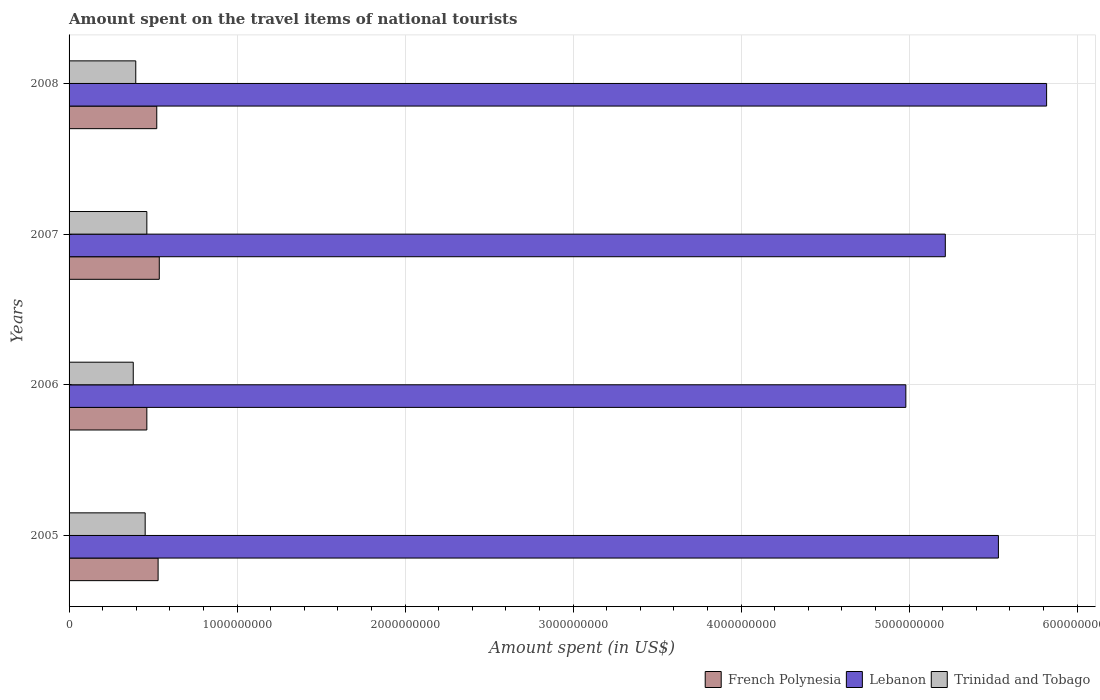Are the number of bars on each tick of the Y-axis equal?
Your response must be concise. Yes. How many bars are there on the 3rd tick from the top?
Keep it short and to the point. 3. What is the label of the 2nd group of bars from the top?
Ensure brevity in your answer.  2007. What is the amount spent on the travel items of national tourists in Trinidad and Tobago in 2008?
Your answer should be very brief. 3.97e+08. Across all years, what is the maximum amount spent on the travel items of national tourists in Lebanon?
Offer a very short reply. 5.82e+09. Across all years, what is the minimum amount spent on the travel items of national tourists in Lebanon?
Provide a short and direct response. 4.98e+09. In which year was the amount spent on the travel items of national tourists in Lebanon minimum?
Keep it short and to the point. 2006. What is the total amount spent on the travel items of national tourists in French Polynesia in the graph?
Your answer should be compact. 2.05e+09. What is the difference between the amount spent on the travel items of national tourists in French Polynesia in 2005 and that in 2007?
Keep it short and to the point. -7.00e+06. What is the difference between the amount spent on the travel items of national tourists in Trinidad and Tobago in 2006 and the amount spent on the travel items of national tourists in Lebanon in 2007?
Offer a very short reply. -4.83e+09. What is the average amount spent on the travel items of national tourists in French Polynesia per year?
Keep it short and to the point. 5.13e+08. In the year 2005, what is the difference between the amount spent on the travel items of national tourists in Trinidad and Tobago and amount spent on the travel items of national tourists in Lebanon?
Ensure brevity in your answer.  -5.08e+09. In how many years, is the amount spent on the travel items of national tourists in Lebanon greater than 600000000 US$?
Your answer should be very brief. 4. What is the ratio of the amount spent on the travel items of national tourists in Trinidad and Tobago in 2006 to that in 2008?
Give a very brief answer. 0.96. Is the amount spent on the travel items of national tourists in Trinidad and Tobago in 2006 less than that in 2008?
Your answer should be very brief. Yes. What is the difference between the highest and the lowest amount spent on the travel items of national tourists in French Polynesia?
Ensure brevity in your answer.  7.40e+07. In how many years, is the amount spent on the travel items of national tourists in Lebanon greater than the average amount spent on the travel items of national tourists in Lebanon taken over all years?
Make the answer very short. 2. Is the sum of the amount spent on the travel items of national tourists in French Polynesia in 2006 and 2007 greater than the maximum amount spent on the travel items of national tourists in Trinidad and Tobago across all years?
Give a very brief answer. Yes. What does the 3rd bar from the top in 2006 represents?
Offer a terse response. French Polynesia. What does the 3rd bar from the bottom in 2008 represents?
Provide a short and direct response. Trinidad and Tobago. Is it the case that in every year, the sum of the amount spent on the travel items of national tourists in Trinidad and Tobago and amount spent on the travel items of national tourists in French Polynesia is greater than the amount spent on the travel items of national tourists in Lebanon?
Provide a succinct answer. No. How many years are there in the graph?
Offer a very short reply. 4. What is the difference between two consecutive major ticks on the X-axis?
Offer a terse response. 1.00e+09. Does the graph contain grids?
Ensure brevity in your answer.  Yes. Where does the legend appear in the graph?
Provide a short and direct response. Bottom right. How many legend labels are there?
Keep it short and to the point. 3. What is the title of the graph?
Give a very brief answer. Amount spent on the travel items of national tourists. Does "Fiji" appear as one of the legend labels in the graph?
Ensure brevity in your answer.  No. What is the label or title of the X-axis?
Your answer should be compact. Amount spent (in US$). What is the label or title of the Y-axis?
Offer a terse response. Years. What is the Amount spent (in US$) of French Polynesia in 2005?
Provide a succinct answer. 5.30e+08. What is the Amount spent (in US$) in Lebanon in 2005?
Offer a very short reply. 5.53e+09. What is the Amount spent (in US$) in Trinidad and Tobago in 2005?
Keep it short and to the point. 4.53e+08. What is the Amount spent (in US$) of French Polynesia in 2006?
Ensure brevity in your answer.  4.63e+08. What is the Amount spent (in US$) of Lebanon in 2006?
Provide a short and direct response. 4.98e+09. What is the Amount spent (in US$) in Trinidad and Tobago in 2006?
Offer a very short reply. 3.82e+08. What is the Amount spent (in US$) in French Polynesia in 2007?
Your answer should be compact. 5.37e+08. What is the Amount spent (in US$) in Lebanon in 2007?
Give a very brief answer. 5.22e+09. What is the Amount spent (in US$) of Trinidad and Tobago in 2007?
Ensure brevity in your answer.  4.63e+08. What is the Amount spent (in US$) in French Polynesia in 2008?
Your response must be concise. 5.22e+08. What is the Amount spent (in US$) of Lebanon in 2008?
Your answer should be compact. 5.82e+09. What is the Amount spent (in US$) in Trinidad and Tobago in 2008?
Your answer should be compact. 3.97e+08. Across all years, what is the maximum Amount spent (in US$) of French Polynesia?
Ensure brevity in your answer.  5.37e+08. Across all years, what is the maximum Amount spent (in US$) of Lebanon?
Your response must be concise. 5.82e+09. Across all years, what is the maximum Amount spent (in US$) of Trinidad and Tobago?
Offer a terse response. 4.63e+08. Across all years, what is the minimum Amount spent (in US$) of French Polynesia?
Give a very brief answer. 4.63e+08. Across all years, what is the minimum Amount spent (in US$) in Lebanon?
Offer a very short reply. 4.98e+09. Across all years, what is the minimum Amount spent (in US$) of Trinidad and Tobago?
Provide a succinct answer. 3.82e+08. What is the total Amount spent (in US$) of French Polynesia in the graph?
Keep it short and to the point. 2.05e+09. What is the total Amount spent (in US$) of Lebanon in the graph?
Ensure brevity in your answer.  2.15e+1. What is the total Amount spent (in US$) of Trinidad and Tobago in the graph?
Ensure brevity in your answer.  1.70e+09. What is the difference between the Amount spent (in US$) in French Polynesia in 2005 and that in 2006?
Provide a succinct answer. 6.70e+07. What is the difference between the Amount spent (in US$) of Lebanon in 2005 and that in 2006?
Make the answer very short. 5.51e+08. What is the difference between the Amount spent (in US$) in Trinidad and Tobago in 2005 and that in 2006?
Provide a short and direct response. 7.10e+07. What is the difference between the Amount spent (in US$) in French Polynesia in 2005 and that in 2007?
Offer a very short reply. -7.00e+06. What is the difference between the Amount spent (in US$) of Lebanon in 2005 and that in 2007?
Provide a short and direct response. 3.16e+08. What is the difference between the Amount spent (in US$) in Trinidad and Tobago in 2005 and that in 2007?
Make the answer very short. -1.00e+07. What is the difference between the Amount spent (in US$) of Lebanon in 2005 and that in 2008?
Your answer should be compact. -2.87e+08. What is the difference between the Amount spent (in US$) in Trinidad and Tobago in 2005 and that in 2008?
Your answer should be compact. 5.60e+07. What is the difference between the Amount spent (in US$) of French Polynesia in 2006 and that in 2007?
Provide a short and direct response. -7.40e+07. What is the difference between the Amount spent (in US$) of Lebanon in 2006 and that in 2007?
Offer a terse response. -2.35e+08. What is the difference between the Amount spent (in US$) in Trinidad and Tobago in 2006 and that in 2007?
Make the answer very short. -8.10e+07. What is the difference between the Amount spent (in US$) in French Polynesia in 2006 and that in 2008?
Your response must be concise. -5.90e+07. What is the difference between the Amount spent (in US$) of Lebanon in 2006 and that in 2008?
Your answer should be very brief. -8.38e+08. What is the difference between the Amount spent (in US$) in Trinidad and Tobago in 2006 and that in 2008?
Keep it short and to the point. -1.50e+07. What is the difference between the Amount spent (in US$) of French Polynesia in 2007 and that in 2008?
Offer a terse response. 1.50e+07. What is the difference between the Amount spent (in US$) of Lebanon in 2007 and that in 2008?
Make the answer very short. -6.03e+08. What is the difference between the Amount spent (in US$) of Trinidad and Tobago in 2007 and that in 2008?
Provide a succinct answer. 6.60e+07. What is the difference between the Amount spent (in US$) of French Polynesia in 2005 and the Amount spent (in US$) of Lebanon in 2006?
Provide a succinct answer. -4.45e+09. What is the difference between the Amount spent (in US$) in French Polynesia in 2005 and the Amount spent (in US$) in Trinidad and Tobago in 2006?
Make the answer very short. 1.48e+08. What is the difference between the Amount spent (in US$) in Lebanon in 2005 and the Amount spent (in US$) in Trinidad and Tobago in 2006?
Your answer should be compact. 5.15e+09. What is the difference between the Amount spent (in US$) in French Polynesia in 2005 and the Amount spent (in US$) in Lebanon in 2007?
Offer a terse response. -4.69e+09. What is the difference between the Amount spent (in US$) in French Polynesia in 2005 and the Amount spent (in US$) in Trinidad and Tobago in 2007?
Your answer should be very brief. 6.70e+07. What is the difference between the Amount spent (in US$) in Lebanon in 2005 and the Amount spent (in US$) in Trinidad and Tobago in 2007?
Offer a terse response. 5.07e+09. What is the difference between the Amount spent (in US$) of French Polynesia in 2005 and the Amount spent (in US$) of Lebanon in 2008?
Your answer should be compact. -5.29e+09. What is the difference between the Amount spent (in US$) of French Polynesia in 2005 and the Amount spent (in US$) of Trinidad and Tobago in 2008?
Offer a terse response. 1.33e+08. What is the difference between the Amount spent (in US$) of Lebanon in 2005 and the Amount spent (in US$) of Trinidad and Tobago in 2008?
Ensure brevity in your answer.  5.14e+09. What is the difference between the Amount spent (in US$) of French Polynesia in 2006 and the Amount spent (in US$) of Lebanon in 2007?
Your response must be concise. -4.75e+09. What is the difference between the Amount spent (in US$) of Lebanon in 2006 and the Amount spent (in US$) of Trinidad and Tobago in 2007?
Keep it short and to the point. 4.52e+09. What is the difference between the Amount spent (in US$) of French Polynesia in 2006 and the Amount spent (in US$) of Lebanon in 2008?
Offer a terse response. -5.36e+09. What is the difference between the Amount spent (in US$) in French Polynesia in 2006 and the Amount spent (in US$) in Trinidad and Tobago in 2008?
Offer a terse response. 6.60e+07. What is the difference between the Amount spent (in US$) of Lebanon in 2006 and the Amount spent (in US$) of Trinidad and Tobago in 2008?
Give a very brief answer. 4.58e+09. What is the difference between the Amount spent (in US$) of French Polynesia in 2007 and the Amount spent (in US$) of Lebanon in 2008?
Provide a succinct answer. -5.28e+09. What is the difference between the Amount spent (in US$) of French Polynesia in 2007 and the Amount spent (in US$) of Trinidad and Tobago in 2008?
Make the answer very short. 1.40e+08. What is the difference between the Amount spent (in US$) of Lebanon in 2007 and the Amount spent (in US$) of Trinidad and Tobago in 2008?
Provide a short and direct response. 4.82e+09. What is the average Amount spent (in US$) of French Polynesia per year?
Keep it short and to the point. 5.13e+08. What is the average Amount spent (in US$) of Lebanon per year?
Provide a succinct answer. 5.39e+09. What is the average Amount spent (in US$) of Trinidad and Tobago per year?
Make the answer very short. 4.24e+08. In the year 2005, what is the difference between the Amount spent (in US$) in French Polynesia and Amount spent (in US$) in Lebanon?
Ensure brevity in your answer.  -5.00e+09. In the year 2005, what is the difference between the Amount spent (in US$) of French Polynesia and Amount spent (in US$) of Trinidad and Tobago?
Provide a short and direct response. 7.70e+07. In the year 2005, what is the difference between the Amount spent (in US$) of Lebanon and Amount spent (in US$) of Trinidad and Tobago?
Ensure brevity in your answer.  5.08e+09. In the year 2006, what is the difference between the Amount spent (in US$) in French Polynesia and Amount spent (in US$) in Lebanon?
Offer a terse response. -4.52e+09. In the year 2006, what is the difference between the Amount spent (in US$) of French Polynesia and Amount spent (in US$) of Trinidad and Tobago?
Offer a very short reply. 8.10e+07. In the year 2006, what is the difference between the Amount spent (in US$) in Lebanon and Amount spent (in US$) in Trinidad and Tobago?
Offer a terse response. 4.60e+09. In the year 2007, what is the difference between the Amount spent (in US$) in French Polynesia and Amount spent (in US$) in Lebanon?
Provide a short and direct response. -4.68e+09. In the year 2007, what is the difference between the Amount spent (in US$) in French Polynesia and Amount spent (in US$) in Trinidad and Tobago?
Offer a terse response. 7.40e+07. In the year 2007, what is the difference between the Amount spent (in US$) in Lebanon and Amount spent (in US$) in Trinidad and Tobago?
Offer a very short reply. 4.75e+09. In the year 2008, what is the difference between the Amount spent (in US$) of French Polynesia and Amount spent (in US$) of Lebanon?
Keep it short and to the point. -5.30e+09. In the year 2008, what is the difference between the Amount spent (in US$) of French Polynesia and Amount spent (in US$) of Trinidad and Tobago?
Your response must be concise. 1.25e+08. In the year 2008, what is the difference between the Amount spent (in US$) of Lebanon and Amount spent (in US$) of Trinidad and Tobago?
Your answer should be very brief. 5.42e+09. What is the ratio of the Amount spent (in US$) in French Polynesia in 2005 to that in 2006?
Your response must be concise. 1.14. What is the ratio of the Amount spent (in US$) of Lebanon in 2005 to that in 2006?
Ensure brevity in your answer.  1.11. What is the ratio of the Amount spent (in US$) of Trinidad and Tobago in 2005 to that in 2006?
Offer a very short reply. 1.19. What is the ratio of the Amount spent (in US$) in Lebanon in 2005 to that in 2007?
Your answer should be compact. 1.06. What is the ratio of the Amount spent (in US$) in Trinidad and Tobago in 2005 to that in 2007?
Provide a short and direct response. 0.98. What is the ratio of the Amount spent (in US$) of French Polynesia in 2005 to that in 2008?
Give a very brief answer. 1.02. What is the ratio of the Amount spent (in US$) of Lebanon in 2005 to that in 2008?
Ensure brevity in your answer.  0.95. What is the ratio of the Amount spent (in US$) of Trinidad and Tobago in 2005 to that in 2008?
Provide a short and direct response. 1.14. What is the ratio of the Amount spent (in US$) in French Polynesia in 2006 to that in 2007?
Provide a succinct answer. 0.86. What is the ratio of the Amount spent (in US$) of Lebanon in 2006 to that in 2007?
Your response must be concise. 0.95. What is the ratio of the Amount spent (in US$) of Trinidad and Tobago in 2006 to that in 2007?
Your answer should be very brief. 0.83. What is the ratio of the Amount spent (in US$) in French Polynesia in 2006 to that in 2008?
Ensure brevity in your answer.  0.89. What is the ratio of the Amount spent (in US$) of Lebanon in 2006 to that in 2008?
Offer a very short reply. 0.86. What is the ratio of the Amount spent (in US$) in Trinidad and Tobago in 2006 to that in 2008?
Offer a very short reply. 0.96. What is the ratio of the Amount spent (in US$) in French Polynesia in 2007 to that in 2008?
Your answer should be very brief. 1.03. What is the ratio of the Amount spent (in US$) in Lebanon in 2007 to that in 2008?
Offer a terse response. 0.9. What is the ratio of the Amount spent (in US$) of Trinidad and Tobago in 2007 to that in 2008?
Your answer should be compact. 1.17. What is the difference between the highest and the second highest Amount spent (in US$) in Lebanon?
Offer a very short reply. 2.87e+08. What is the difference between the highest and the lowest Amount spent (in US$) of French Polynesia?
Your answer should be compact. 7.40e+07. What is the difference between the highest and the lowest Amount spent (in US$) in Lebanon?
Offer a very short reply. 8.38e+08. What is the difference between the highest and the lowest Amount spent (in US$) in Trinidad and Tobago?
Provide a short and direct response. 8.10e+07. 